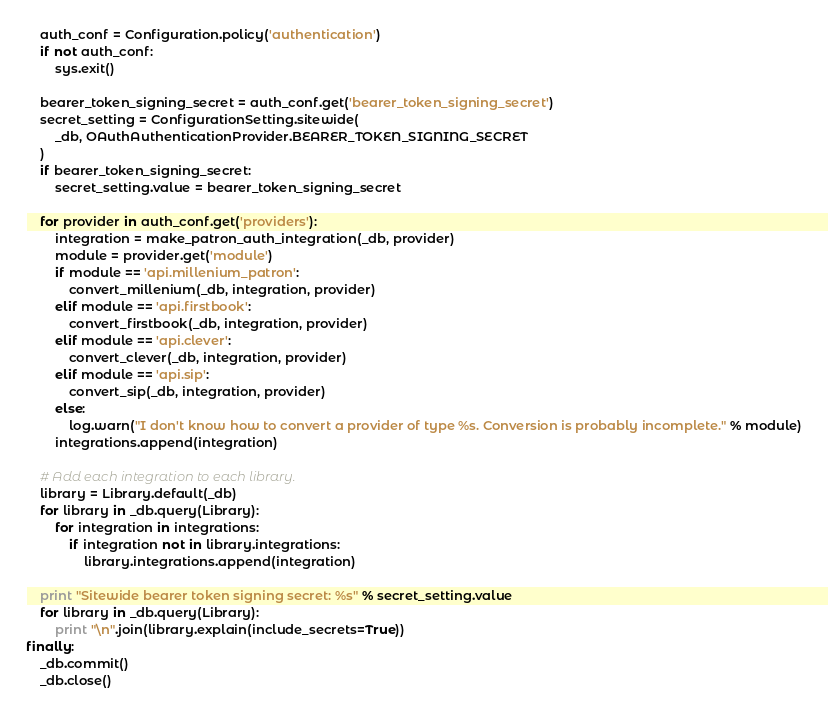<code> <loc_0><loc_0><loc_500><loc_500><_Python_>    auth_conf = Configuration.policy('authentication')
    if not auth_conf:
        sys.exit()

    bearer_token_signing_secret = auth_conf.get('bearer_token_signing_secret')
    secret_setting = ConfigurationSetting.sitewide(
        _db, OAuthAuthenticationProvider.BEARER_TOKEN_SIGNING_SECRET
    )
    if bearer_token_signing_secret:
        secret_setting.value = bearer_token_signing_secret

    for provider in auth_conf.get('providers'):
        integration = make_patron_auth_integration(_db, provider)
        module = provider.get('module')
        if module == 'api.millenium_patron':
            convert_millenium(_db, integration, provider)
        elif module == 'api.firstbook':
            convert_firstbook(_db, integration, provider)
        elif module == 'api.clever':
            convert_clever(_db, integration, provider)
        elif module == 'api.sip':
            convert_sip(_db, integration, provider)
        else:
            log.warn("I don't know how to convert a provider of type %s. Conversion is probably incomplete." % module)
        integrations.append(integration)

    # Add each integration to each library.
    library = Library.default(_db)
    for library in _db.query(Library):
        for integration in integrations:
            if integration not in library.integrations:
                library.integrations.append(integration)

    print "Sitewide bearer token signing secret: %s" % secret_setting.value
    for library in _db.query(Library):
        print "\n".join(library.explain(include_secrets=True))
finally:
    _db.commit()
    _db.close()
</code> 